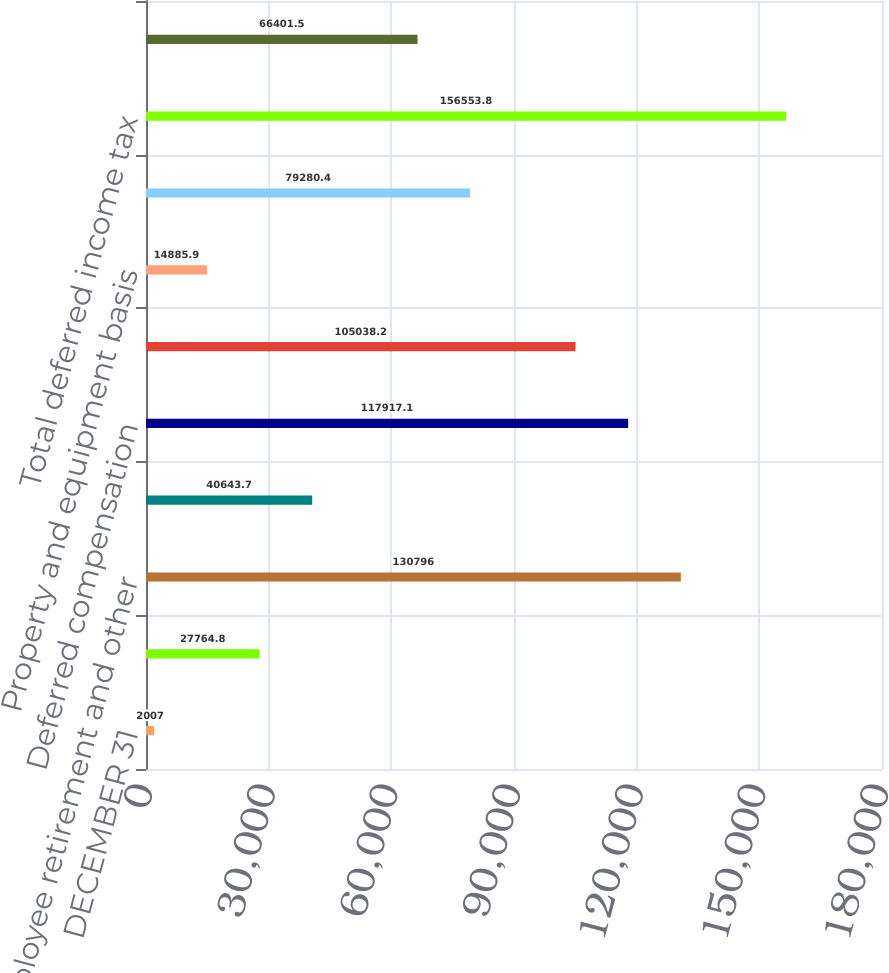<chart> <loc_0><loc_0><loc_500><loc_500><bar_chart><fcel>DECEMBER 31<fcel>Provision for bad debts<fcel>Employee retirement and other<fcel>Workers' compensation<fcel>Deferred compensation<fcel>Credits and net operating loss<fcel>Property and equipment basis<fcel>Other<fcel>Total deferred income tax<fcel>Amortization of intangible<nl><fcel>2007<fcel>27764.8<fcel>130796<fcel>40643.7<fcel>117917<fcel>105038<fcel>14885.9<fcel>79280.4<fcel>156554<fcel>66401.5<nl></chart> 